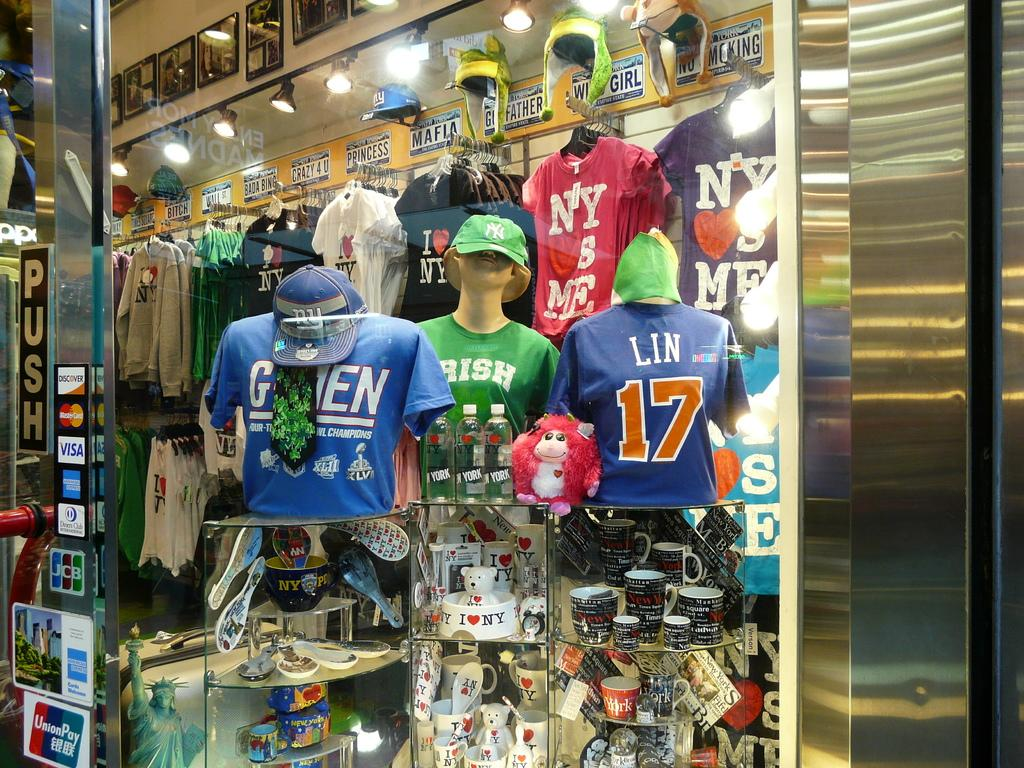<image>
Offer a succinct explanation of the picture presented. A storefront window full of sports shirt including Lin 17. 